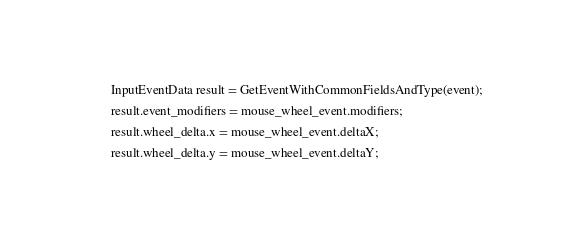Convert code to text. <code><loc_0><loc_0><loc_500><loc_500><_C++_>  InputEventData result = GetEventWithCommonFieldsAndType(event);
  result.event_modifiers = mouse_wheel_event.modifiers;
  result.wheel_delta.x = mouse_wheel_event.deltaX;
  result.wheel_delta.y = mouse_wheel_event.deltaY;</code> 